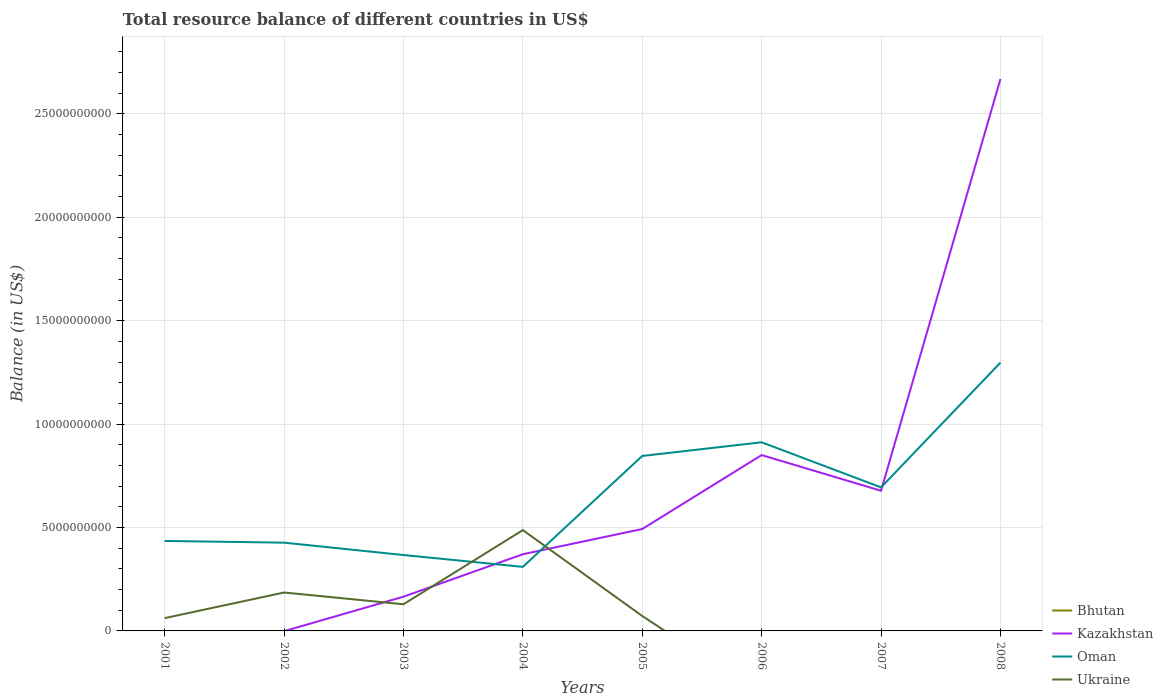Is the number of lines equal to the number of legend labels?
Provide a succinct answer. No. Across all years, what is the maximum total resource balance in Oman?
Offer a terse response. 3.10e+09. What is the total total resource balance in Oman in the graph?
Keep it short and to the point. -6.02e+09. What is the difference between the highest and the second highest total resource balance in Ukraine?
Offer a very short reply. 4.87e+09. What is the difference between the highest and the lowest total resource balance in Kazakhstan?
Make the answer very short. 3. Is the total resource balance in Bhutan strictly greater than the total resource balance in Kazakhstan over the years?
Your answer should be compact. No. Are the values on the major ticks of Y-axis written in scientific E-notation?
Your answer should be compact. No. Does the graph contain any zero values?
Provide a succinct answer. Yes. What is the title of the graph?
Provide a succinct answer. Total resource balance of different countries in US$. Does "San Marino" appear as one of the legend labels in the graph?
Provide a succinct answer. No. What is the label or title of the X-axis?
Give a very brief answer. Years. What is the label or title of the Y-axis?
Offer a terse response. Balance (in US$). What is the Balance (in US$) of Bhutan in 2001?
Make the answer very short. 0. What is the Balance (in US$) of Oman in 2001?
Your response must be concise. 4.35e+09. What is the Balance (in US$) in Ukraine in 2001?
Your answer should be compact. 6.18e+08. What is the Balance (in US$) in Bhutan in 2002?
Give a very brief answer. 0. What is the Balance (in US$) in Oman in 2002?
Your answer should be compact. 4.27e+09. What is the Balance (in US$) of Ukraine in 2002?
Give a very brief answer. 1.86e+09. What is the Balance (in US$) of Kazakhstan in 2003?
Keep it short and to the point. 1.66e+09. What is the Balance (in US$) in Oman in 2003?
Give a very brief answer. 3.67e+09. What is the Balance (in US$) in Ukraine in 2003?
Make the answer very short. 1.29e+09. What is the Balance (in US$) of Kazakhstan in 2004?
Your response must be concise. 3.71e+09. What is the Balance (in US$) of Oman in 2004?
Your answer should be very brief. 3.10e+09. What is the Balance (in US$) in Ukraine in 2004?
Give a very brief answer. 4.87e+09. What is the Balance (in US$) of Kazakhstan in 2005?
Provide a succinct answer. 4.93e+09. What is the Balance (in US$) in Oman in 2005?
Provide a short and direct response. 8.46e+09. What is the Balance (in US$) in Ukraine in 2005?
Offer a very short reply. 7.21e+08. What is the Balance (in US$) in Bhutan in 2006?
Provide a short and direct response. 0. What is the Balance (in US$) in Kazakhstan in 2006?
Provide a succinct answer. 8.50e+09. What is the Balance (in US$) in Oman in 2006?
Your answer should be very brief. 9.12e+09. What is the Balance (in US$) of Ukraine in 2006?
Make the answer very short. 0. What is the Balance (in US$) in Bhutan in 2007?
Keep it short and to the point. 0. What is the Balance (in US$) in Kazakhstan in 2007?
Offer a very short reply. 6.78e+09. What is the Balance (in US$) of Oman in 2007?
Ensure brevity in your answer.  6.94e+09. What is the Balance (in US$) in Ukraine in 2007?
Provide a short and direct response. 0. What is the Balance (in US$) of Kazakhstan in 2008?
Your response must be concise. 2.67e+1. What is the Balance (in US$) of Oman in 2008?
Give a very brief answer. 1.30e+1. What is the Balance (in US$) of Ukraine in 2008?
Your answer should be very brief. 0. Across all years, what is the maximum Balance (in US$) in Kazakhstan?
Give a very brief answer. 2.67e+1. Across all years, what is the maximum Balance (in US$) of Oman?
Your answer should be compact. 1.30e+1. Across all years, what is the maximum Balance (in US$) of Ukraine?
Your answer should be very brief. 4.87e+09. Across all years, what is the minimum Balance (in US$) in Kazakhstan?
Keep it short and to the point. 0. Across all years, what is the minimum Balance (in US$) of Oman?
Provide a succinct answer. 3.10e+09. Across all years, what is the minimum Balance (in US$) of Ukraine?
Offer a terse response. 0. What is the total Balance (in US$) of Bhutan in the graph?
Provide a succinct answer. 0. What is the total Balance (in US$) of Kazakhstan in the graph?
Your answer should be compact. 5.23e+1. What is the total Balance (in US$) in Oman in the graph?
Keep it short and to the point. 5.29e+1. What is the total Balance (in US$) of Ukraine in the graph?
Provide a short and direct response. 9.36e+09. What is the difference between the Balance (in US$) in Oman in 2001 and that in 2002?
Your answer should be very brief. 8.32e+07. What is the difference between the Balance (in US$) of Ukraine in 2001 and that in 2002?
Give a very brief answer. -1.24e+09. What is the difference between the Balance (in US$) in Oman in 2001 and that in 2003?
Your response must be concise. 6.81e+08. What is the difference between the Balance (in US$) in Ukraine in 2001 and that in 2003?
Your response must be concise. -6.70e+08. What is the difference between the Balance (in US$) in Oman in 2001 and that in 2004?
Your answer should be compact. 1.25e+09. What is the difference between the Balance (in US$) in Ukraine in 2001 and that in 2004?
Provide a short and direct response. -4.26e+09. What is the difference between the Balance (in US$) of Oman in 2001 and that in 2005?
Provide a short and direct response. -4.11e+09. What is the difference between the Balance (in US$) of Ukraine in 2001 and that in 2005?
Keep it short and to the point. -1.03e+08. What is the difference between the Balance (in US$) of Oman in 2001 and that in 2006?
Provide a short and direct response. -4.77e+09. What is the difference between the Balance (in US$) of Oman in 2001 and that in 2007?
Provide a succinct answer. -2.59e+09. What is the difference between the Balance (in US$) in Oman in 2001 and that in 2008?
Offer a terse response. -8.62e+09. What is the difference between the Balance (in US$) of Oman in 2002 and that in 2003?
Offer a terse response. 5.98e+08. What is the difference between the Balance (in US$) in Ukraine in 2002 and that in 2003?
Offer a very short reply. 5.69e+08. What is the difference between the Balance (in US$) of Oman in 2002 and that in 2004?
Keep it short and to the point. 1.17e+09. What is the difference between the Balance (in US$) of Ukraine in 2002 and that in 2004?
Your answer should be very brief. -3.02e+09. What is the difference between the Balance (in US$) of Oman in 2002 and that in 2005?
Make the answer very short. -4.19e+09. What is the difference between the Balance (in US$) of Ukraine in 2002 and that in 2005?
Keep it short and to the point. 1.14e+09. What is the difference between the Balance (in US$) of Oman in 2002 and that in 2006?
Offer a very short reply. -4.85e+09. What is the difference between the Balance (in US$) in Oman in 2002 and that in 2007?
Keep it short and to the point. -2.67e+09. What is the difference between the Balance (in US$) in Oman in 2002 and that in 2008?
Keep it short and to the point. -8.70e+09. What is the difference between the Balance (in US$) of Kazakhstan in 2003 and that in 2004?
Your answer should be compact. -2.05e+09. What is the difference between the Balance (in US$) in Oman in 2003 and that in 2004?
Provide a short and direct response. 5.72e+08. What is the difference between the Balance (in US$) in Ukraine in 2003 and that in 2004?
Offer a very short reply. -3.59e+09. What is the difference between the Balance (in US$) in Kazakhstan in 2003 and that in 2005?
Ensure brevity in your answer.  -3.27e+09. What is the difference between the Balance (in US$) in Oman in 2003 and that in 2005?
Give a very brief answer. -4.79e+09. What is the difference between the Balance (in US$) in Ukraine in 2003 and that in 2005?
Your answer should be very brief. 5.67e+08. What is the difference between the Balance (in US$) of Kazakhstan in 2003 and that in 2006?
Offer a terse response. -6.85e+09. What is the difference between the Balance (in US$) in Oman in 2003 and that in 2006?
Your answer should be compact. -5.45e+09. What is the difference between the Balance (in US$) in Kazakhstan in 2003 and that in 2007?
Your response must be concise. -5.12e+09. What is the difference between the Balance (in US$) in Oman in 2003 and that in 2007?
Make the answer very short. -3.27e+09. What is the difference between the Balance (in US$) of Kazakhstan in 2003 and that in 2008?
Offer a terse response. -2.50e+1. What is the difference between the Balance (in US$) of Oman in 2003 and that in 2008?
Keep it short and to the point. -9.30e+09. What is the difference between the Balance (in US$) in Kazakhstan in 2004 and that in 2005?
Your response must be concise. -1.22e+09. What is the difference between the Balance (in US$) in Oman in 2004 and that in 2005?
Keep it short and to the point. -5.36e+09. What is the difference between the Balance (in US$) in Ukraine in 2004 and that in 2005?
Make the answer very short. 4.15e+09. What is the difference between the Balance (in US$) of Kazakhstan in 2004 and that in 2006?
Keep it short and to the point. -4.80e+09. What is the difference between the Balance (in US$) of Oman in 2004 and that in 2006?
Give a very brief answer. -6.02e+09. What is the difference between the Balance (in US$) of Kazakhstan in 2004 and that in 2007?
Provide a short and direct response. -3.07e+09. What is the difference between the Balance (in US$) of Oman in 2004 and that in 2007?
Your response must be concise. -3.84e+09. What is the difference between the Balance (in US$) of Kazakhstan in 2004 and that in 2008?
Your answer should be compact. -2.30e+1. What is the difference between the Balance (in US$) in Oman in 2004 and that in 2008?
Make the answer very short. -9.88e+09. What is the difference between the Balance (in US$) in Kazakhstan in 2005 and that in 2006?
Provide a succinct answer. -3.58e+09. What is the difference between the Balance (in US$) in Oman in 2005 and that in 2006?
Your response must be concise. -6.61e+08. What is the difference between the Balance (in US$) in Kazakhstan in 2005 and that in 2007?
Your response must be concise. -1.85e+09. What is the difference between the Balance (in US$) in Oman in 2005 and that in 2007?
Give a very brief answer. 1.52e+09. What is the difference between the Balance (in US$) of Kazakhstan in 2005 and that in 2008?
Your response must be concise. -2.18e+1. What is the difference between the Balance (in US$) of Oman in 2005 and that in 2008?
Provide a succinct answer. -4.51e+09. What is the difference between the Balance (in US$) of Kazakhstan in 2006 and that in 2007?
Ensure brevity in your answer.  1.73e+09. What is the difference between the Balance (in US$) of Oman in 2006 and that in 2007?
Keep it short and to the point. 2.18e+09. What is the difference between the Balance (in US$) in Kazakhstan in 2006 and that in 2008?
Provide a succinct answer. -1.82e+1. What is the difference between the Balance (in US$) in Oman in 2006 and that in 2008?
Keep it short and to the point. -3.85e+09. What is the difference between the Balance (in US$) in Kazakhstan in 2007 and that in 2008?
Provide a short and direct response. -1.99e+1. What is the difference between the Balance (in US$) in Oman in 2007 and that in 2008?
Make the answer very short. -6.03e+09. What is the difference between the Balance (in US$) of Oman in 2001 and the Balance (in US$) of Ukraine in 2002?
Offer a terse response. 2.49e+09. What is the difference between the Balance (in US$) in Oman in 2001 and the Balance (in US$) in Ukraine in 2003?
Provide a short and direct response. 3.06e+09. What is the difference between the Balance (in US$) of Oman in 2001 and the Balance (in US$) of Ukraine in 2004?
Offer a very short reply. -5.24e+08. What is the difference between the Balance (in US$) in Oman in 2001 and the Balance (in US$) in Ukraine in 2005?
Your answer should be compact. 3.63e+09. What is the difference between the Balance (in US$) of Oman in 2002 and the Balance (in US$) of Ukraine in 2003?
Offer a very short reply. 2.98e+09. What is the difference between the Balance (in US$) in Oman in 2002 and the Balance (in US$) in Ukraine in 2004?
Your answer should be very brief. -6.07e+08. What is the difference between the Balance (in US$) of Oman in 2002 and the Balance (in US$) of Ukraine in 2005?
Make the answer very short. 3.55e+09. What is the difference between the Balance (in US$) of Kazakhstan in 2003 and the Balance (in US$) of Oman in 2004?
Your answer should be compact. -1.44e+09. What is the difference between the Balance (in US$) in Kazakhstan in 2003 and the Balance (in US$) in Ukraine in 2004?
Provide a succinct answer. -3.22e+09. What is the difference between the Balance (in US$) of Oman in 2003 and the Balance (in US$) of Ukraine in 2004?
Your answer should be compact. -1.21e+09. What is the difference between the Balance (in US$) of Kazakhstan in 2003 and the Balance (in US$) of Oman in 2005?
Give a very brief answer. -6.80e+09. What is the difference between the Balance (in US$) of Kazakhstan in 2003 and the Balance (in US$) of Ukraine in 2005?
Your answer should be very brief. 9.35e+08. What is the difference between the Balance (in US$) of Oman in 2003 and the Balance (in US$) of Ukraine in 2005?
Offer a very short reply. 2.95e+09. What is the difference between the Balance (in US$) in Kazakhstan in 2003 and the Balance (in US$) in Oman in 2006?
Provide a short and direct response. -7.46e+09. What is the difference between the Balance (in US$) in Kazakhstan in 2003 and the Balance (in US$) in Oman in 2007?
Give a very brief answer. -5.29e+09. What is the difference between the Balance (in US$) of Kazakhstan in 2003 and the Balance (in US$) of Oman in 2008?
Offer a very short reply. -1.13e+1. What is the difference between the Balance (in US$) of Kazakhstan in 2004 and the Balance (in US$) of Oman in 2005?
Keep it short and to the point. -4.75e+09. What is the difference between the Balance (in US$) of Kazakhstan in 2004 and the Balance (in US$) of Ukraine in 2005?
Give a very brief answer. 2.99e+09. What is the difference between the Balance (in US$) in Oman in 2004 and the Balance (in US$) in Ukraine in 2005?
Keep it short and to the point. 2.38e+09. What is the difference between the Balance (in US$) of Kazakhstan in 2004 and the Balance (in US$) of Oman in 2006?
Give a very brief answer. -5.41e+09. What is the difference between the Balance (in US$) of Kazakhstan in 2004 and the Balance (in US$) of Oman in 2007?
Make the answer very short. -3.23e+09. What is the difference between the Balance (in US$) in Kazakhstan in 2004 and the Balance (in US$) in Oman in 2008?
Your response must be concise. -9.27e+09. What is the difference between the Balance (in US$) in Kazakhstan in 2005 and the Balance (in US$) in Oman in 2006?
Keep it short and to the point. -4.19e+09. What is the difference between the Balance (in US$) of Kazakhstan in 2005 and the Balance (in US$) of Oman in 2007?
Offer a very short reply. -2.01e+09. What is the difference between the Balance (in US$) of Kazakhstan in 2005 and the Balance (in US$) of Oman in 2008?
Your answer should be very brief. -8.05e+09. What is the difference between the Balance (in US$) of Kazakhstan in 2006 and the Balance (in US$) of Oman in 2007?
Your answer should be very brief. 1.56e+09. What is the difference between the Balance (in US$) of Kazakhstan in 2006 and the Balance (in US$) of Oman in 2008?
Your answer should be compact. -4.47e+09. What is the difference between the Balance (in US$) in Kazakhstan in 2007 and the Balance (in US$) in Oman in 2008?
Ensure brevity in your answer.  -6.20e+09. What is the average Balance (in US$) of Kazakhstan per year?
Offer a terse response. 6.53e+09. What is the average Balance (in US$) in Oman per year?
Ensure brevity in your answer.  6.61e+09. What is the average Balance (in US$) in Ukraine per year?
Keep it short and to the point. 1.17e+09. In the year 2001, what is the difference between the Balance (in US$) of Oman and Balance (in US$) of Ukraine?
Give a very brief answer. 3.73e+09. In the year 2002, what is the difference between the Balance (in US$) of Oman and Balance (in US$) of Ukraine?
Provide a short and direct response. 2.41e+09. In the year 2003, what is the difference between the Balance (in US$) in Kazakhstan and Balance (in US$) in Oman?
Your answer should be very brief. -2.01e+09. In the year 2003, what is the difference between the Balance (in US$) of Kazakhstan and Balance (in US$) of Ukraine?
Your response must be concise. 3.68e+08. In the year 2003, what is the difference between the Balance (in US$) of Oman and Balance (in US$) of Ukraine?
Make the answer very short. 2.38e+09. In the year 2004, what is the difference between the Balance (in US$) of Kazakhstan and Balance (in US$) of Oman?
Your answer should be compact. 6.10e+08. In the year 2004, what is the difference between the Balance (in US$) in Kazakhstan and Balance (in US$) in Ukraine?
Keep it short and to the point. -1.17e+09. In the year 2004, what is the difference between the Balance (in US$) of Oman and Balance (in US$) of Ukraine?
Make the answer very short. -1.78e+09. In the year 2005, what is the difference between the Balance (in US$) of Kazakhstan and Balance (in US$) of Oman?
Provide a short and direct response. -3.53e+09. In the year 2005, what is the difference between the Balance (in US$) in Kazakhstan and Balance (in US$) in Ukraine?
Give a very brief answer. 4.21e+09. In the year 2005, what is the difference between the Balance (in US$) in Oman and Balance (in US$) in Ukraine?
Give a very brief answer. 7.74e+09. In the year 2006, what is the difference between the Balance (in US$) of Kazakhstan and Balance (in US$) of Oman?
Your response must be concise. -6.18e+08. In the year 2007, what is the difference between the Balance (in US$) in Kazakhstan and Balance (in US$) in Oman?
Your answer should be compact. -1.64e+08. In the year 2008, what is the difference between the Balance (in US$) of Kazakhstan and Balance (in US$) of Oman?
Your answer should be very brief. 1.37e+1. What is the ratio of the Balance (in US$) in Oman in 2001 to that in 2002?
Your response must be concise. 1.02. What is the ratio of the Balance (in US$) in Ukraine in 2001 to that in 2002?
Offer a terse response. 0.33. What is the ratio of the Balance (in US$) of Oman in 2001 to that in 2003?
Offer a very short reply. 1.19. What is the ratio of the Balance (in US$) of Ukraine in 2001 to that in 2003?
Offer a terse response. 0.48. What is the ratio of the Balance (in US$) of Oman in 2001 to that in 2004?
Offer a very short reply. 1.4. What is the ratio of the Balance (in US$) of Ukraine in 2001 to that in 2004?
Offer a very short reply. 0.13. What is the ratio of the Balance (in US$) of Oman in 2001 to that in 2005?
Offer a very short reply. 0.51. What is the ratio of the Balance (in US$) of Ukraine in 2001 to that in 2005?
Provide a succinct answer. 0.86. What is the ratio of the Balance (in US$) of Oman in 2001 to that in 2006?
Provide a short and direct response. 0.48. What is the ratio of the Balance (in US$) of Oman in 2001 to that in 2007?
Keep it short and to the point. 0.63. What is the ratio of the Balance (in US$) in Oman in 2001 to that in 2008?
Offer a very short reply. 0.34. What is the ratio of the Balance (in US$) in Oman in 2002 to that in 2003?
Make the answer very short. 1.16. What is the ratio of the Balance (in US$) in Ukraine in 2002 to that in 2003?
Your response must be concise. 1.44. What is the ratio of the Balance (in US$) of Oman in 2002 to that in 2004?
Provide a short and direct response. 1.38. What is the ratio of the Balance (in US$) of Ukraine in 2002 to that in 2004?
Your answer should be compact. 0.38. What is the ratio of the Balance (in US$) of Oman in 2002 to that in 2005?
Give a very brief answer. 0.5. What is the ratio of the Balance (in US$) in Ukraine in 2002 to that in 2005?
Give a very brief answer. 2.57. What is the ratio of the Balance (in US$) in Oman in 2002 to that in 2006?
Give a very brief answer. 0.47. What is the ratio of the Balance (in US$) in Oman in 2002 to that in 2007?
Offer a terse response. 0.61. What is the ratio of the Balance (in US$) in Oman in 2002 to that in 2008?
Keep it short and to the point. 0.33. What is the ratio of the Balance (in US$) of Kazakhstan in 2003 to that in 2004?
Ensure brevity in your answer.  0.45. What is the ratio of the Balance (in US$) in Oman in 2003 to that in 2004?
Make the answer very short. 1.18. What is the ratio of the Balance (in US$) in Ukraine in 2003 to that in 2004?
Make the answer very short. 0.26. What is the ratio of the Balance (in US$) in Kazakhstan in 2003 to that in 2005?
Offer a terse response. 0.34. What is the ratio of the Balance (in US$) in Oman in 2003 to that in 2005?
Ensure brevity in your answer.  0.43. What is the ratio of the Balance (in US$) of Ukraine in 2003 to that in 2005?
Provide a succinct answer. 1.79. What is the ratio of the Balance (in US$) of Kazakhstan in 2003 to that in 2006?
Keep it short and to the point. 0.19. What is the ratio of the Balance (in US$) in Oman in 2003 to that in 2006?
Offer a terse response. 0.4. What is the ratio of the Balance (in US$) of Kazakhstan in 2003 to that in 2007?
Give a very brief answer. 0.24. What is the ratio of the Balance (in US$) of Oman in 2003 to that in 2007?
Offer a very short reply. 0.53. What is the ratio of the Balance (in US$) of Kazakhstan in 2003 to that in 2008?
Your response must be concise. 0.06. What is the ratio of the Balance (in US$) of Oman in 2003 to that in 2008?
Provide a short and direct response. 0.28. What is the ratio of the Balance (in US$) in Kazakhstan in 2004 to that in 2005?
Offer a terse response. 0.75. What is the ratio of the Balance (in US$) in Oman in 2004 to that in 2005?
Make the answer very short. 0.37. What is the ratio of the Balance (in US$) of Ukraine in 2004 to that in 2005?
Keep it short and to the point. 6.76. What is the ratio of the Balance (in US$) of Kazakhstan in 2004 to that in 2006?
Offer a terse response. 0.44. What is the ratio of the Balance (in US$) of Oman in 2004 to that in 2006?
Offer a very short reply. 0.34. What is the ratio of the Balance (in US$) of Kazakhstan in 2004 to that in 2007?
Give a very brief answer. 0.55. What is the ratio of the Balance (in US$) of Oman in 2004 to that in 2007?
Ensure brevity in your answer.  0.45. What is the ratio of the Balance (in US$) of Kazakhstan in 2004 to that in 2008?
Provide a succinct answer. 0.14. What is the ratio of the Balance (in US$) in Oman in 2004 to that in 2008?
Provide a short and direct response. 0.24. What is the ratio of the Balance (in US$) of Kazakhstan in 2005 to that in 2006?
Offer a very short reply. 0.58. What is the ratio of the Balance (in US$) in Oman in 2005 to that in 2006?
Offer a terse response. 0.93. What is the ratio of the Balance (in US$) in Kazakhstan in 2005 to that in 2007?
Your answer should be very brief. 0.73. What is the ratio of the Balance (in US$) in Oman in 2005 to that in 2007?
Provide a short and direct response. 1.22. What is the ratio of the Balance (in US$) in Kazakhstan in 2005 to that in 2008?
Offer a very short reply. 0.18. What is the ratio of the Balance (in US$) of Oman in 2005 to that in 2008?
Offer a very short reply. 0.65. What is the ratio of the Balance (in US$) of Kazakhstan in 2006 to that in 2007?
Keep it short and to the point. 1.25. What is the ratio of the Balance (in US$) in Oman in 2006 to that in 2007?
Your answer should be very brief. 1.31. What is the ratio of the Balance (in US$) in Kazakhstan in 2006 to that in 2008?
Ensure brevity in your answer.  0.32. What is the ratio of the Balance (in US$) of Oman in 2006 to that in 2008?
Your response must be concise. 0.7. What is the ratio of the Balance (in US$) in Kazakhstan in 2007 to that in 2008?
Give a very brief answer. 0.25. What is the ratio of the Balance (in US$) of Oman in 2007 to that in 2008?
Offer a very short reply. 0.54. What is the difference between the highest and the second highest Balance (in US$) of Kazakhstan?
Provide a short and direct response. 1.82e+1. What is the difference between the highest and the second highest Balance (in US$) of Oman?
Your answer should be compact. 3.85e+09. What is the difference between the highest and the second highest Balance (in US$) in Ukraine?
Give a very brief answer. 3.02e+09. What is the difference between the highest and the lowest Balance (in US$) of Kazakhstan?
Give a very brief answer. 2.67e+1. What is the difference between the highest and the lowest Balance (in US$) in Oman?
Provide a short and direct response. 9.88e+09. What is the difference between the highest and the lowest Balance (in US$) in Ukraine?
Your response must be concise. 4.87e+09. 